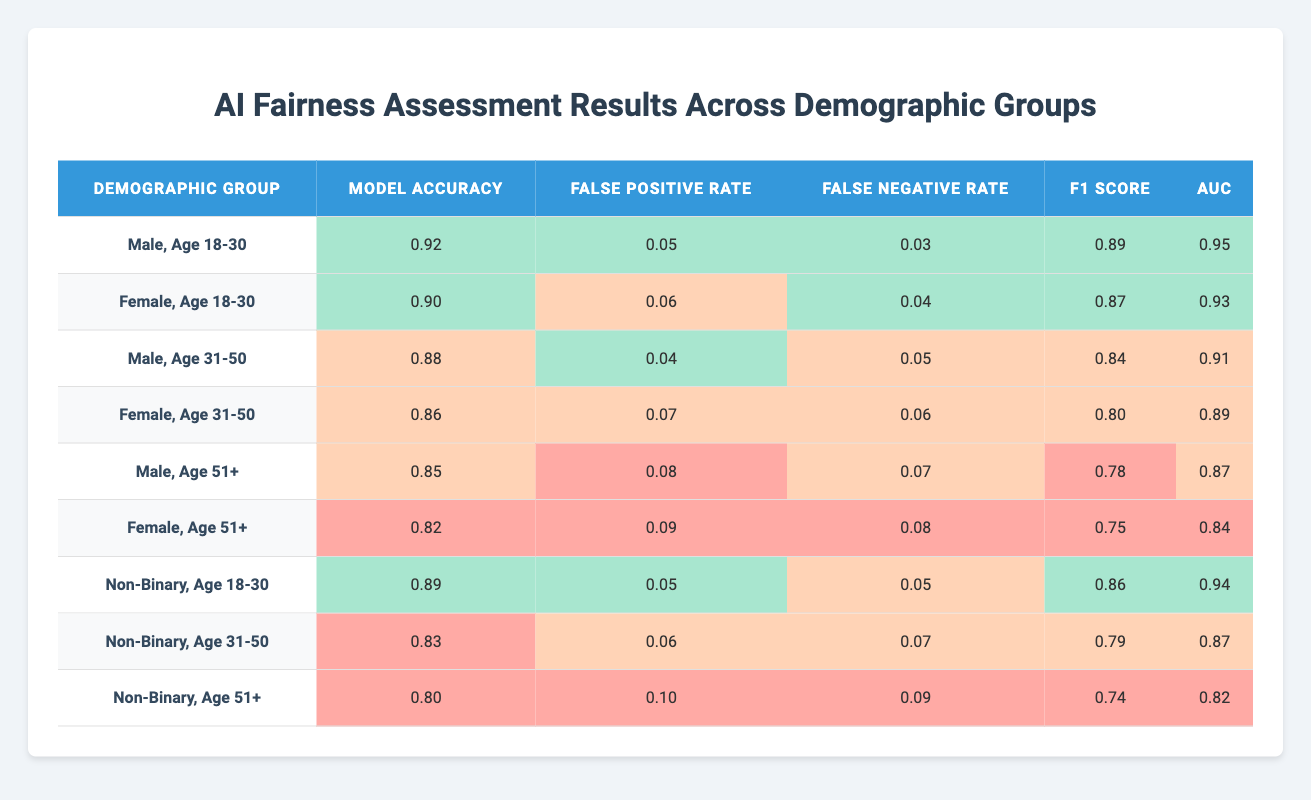What is the model accuracy for males aged 51 and older? The table shows that the model accuracy for the demographic group "Male, Age 51+" is 0.85.
Answer: 0.85 What is the false positive rate for females aged 31-50? The table indicates that the false positive rate for "Female, Age 31-50" is 0.07.
Answer: 0.07 Which demographic group has the lowest F1 score? Comparing the F1 scores listed in the table, the lowest value is for "Female, Age 51+" with an F1 score of 0.75.
Answer: Female, Age 51+ What is the average model accuracy for non-binary individuals across all age groups? The model accuracy values for non-binary individuals are 0.89 (Age 18-30), 0.83 (Age 31-50), and 0.80 (Age 51+). To find the average: (0.89 + 0.83 + 0.80) / 3 = 0.84.
Answer: 0.84 Is the false negative rate for males aged 31-50 higher than that for females aged 51+? The false negative rate for "Male, Age 31-50" is 0.05, and for "Female, Age 51+" it is 0.08. Since 0.05 is less than 0.08, the statement is false.
Answer: No What is the difference in AUC between males aged 18-30 and females aged 31-50? The AUC for "Male, Age 18-30" is 0.95, and for "Female, Age 31-50" it is 0.89. The difference is 0.95 - 0.89 = 0.06.
Answer: 0.06 Which demographic group has the highest AUC? From the table, "Male, Age 18-30" has the highest AUC at 0.95.
Answer: Male, Age 18-30 What is the total model accuracy for all male demographic groups? The model accuracy for male groups is 0.92 (Age 18-30) + 0.88 (Age 31-50) + 0.85 (Age 51+) = 0.92 + 0.88 + 0.85 = 2.65.
Answer: 2.65 Are females aged 18-30 performing better than non-binary individuals aged 31-50 in terms of F1 score? The F1 score for "Female, Age 18-30" is 0.87, while for "Non-Binary, Age 31-50," it is 0.79. Since 0.87 is greater than 0.79, the statement is true.
Answer: Yes What is the combined false positive rate for all non-binary age groups? The false positive rates for non-binary groups are 0.05 (Age 18-30), 0.06 (Age 31-50), and 0.10 (Age 51+). The combined total is 0.05 + 0.06 + 0.10 = 0.21.
Answer: 0.21 